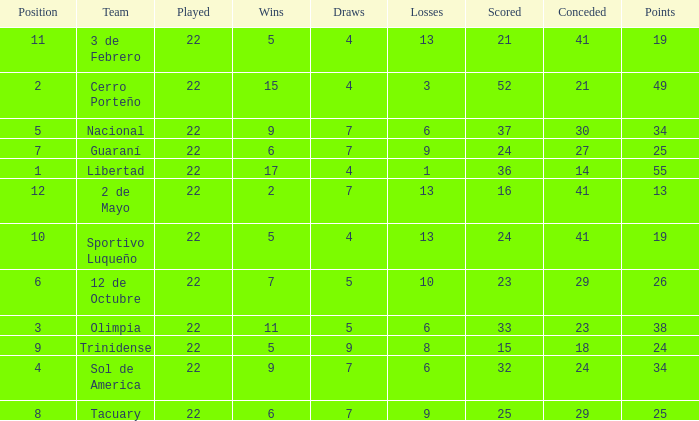What is the number of draws for the team with more than 8 losses and 13 points? 7.0. 